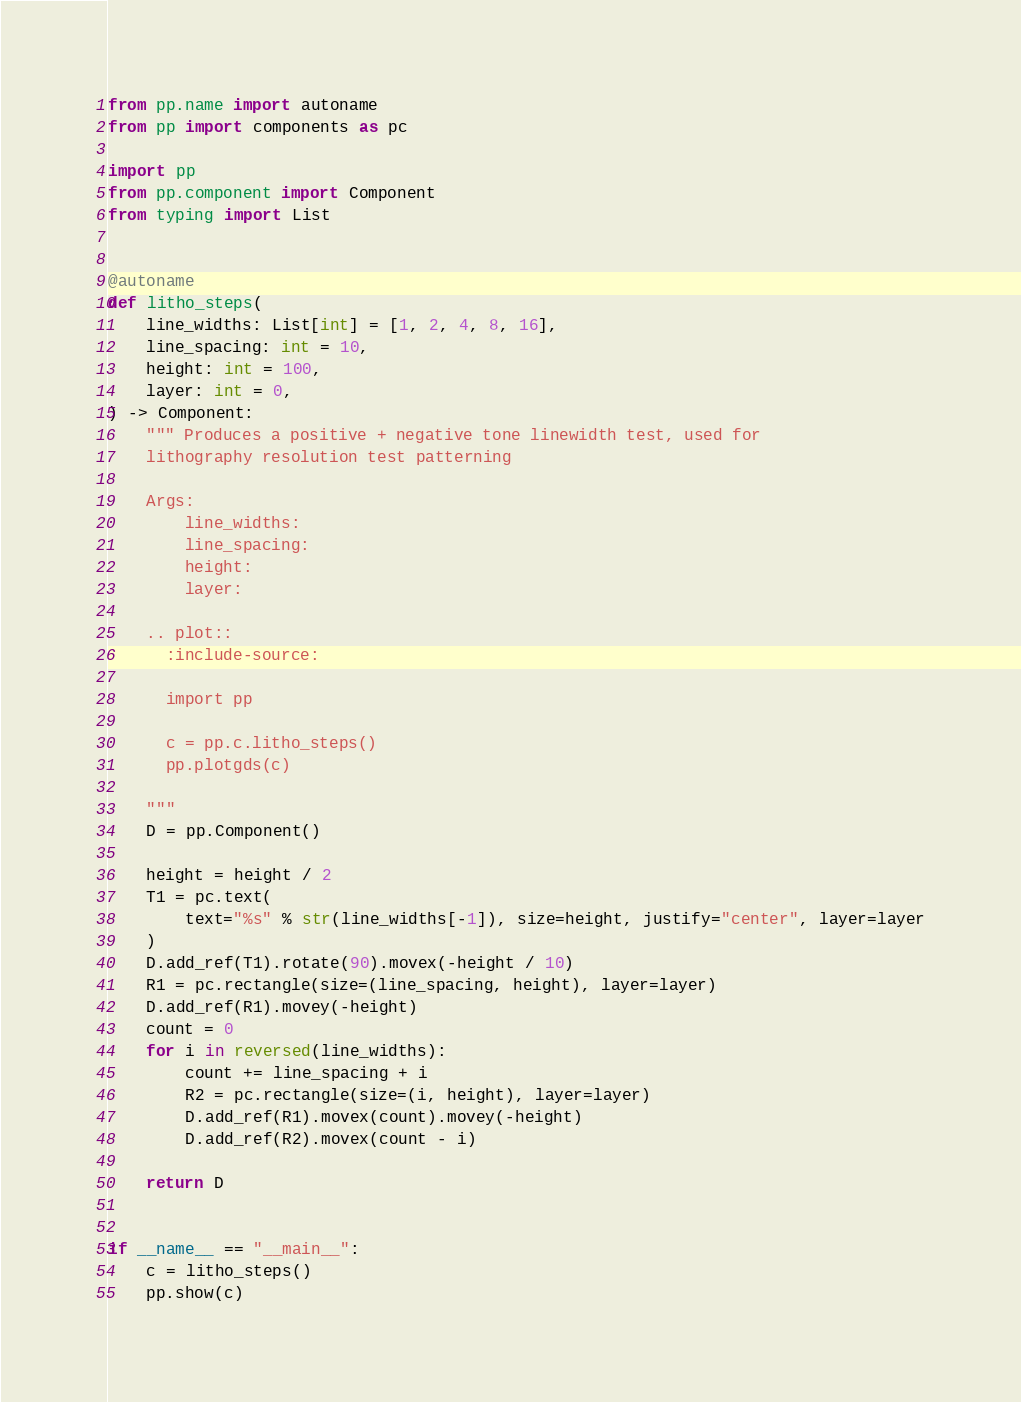<code> <loc_0><loc_0><loc_500><loc_500><_Python_>from pp.name import autoname
from pp import components as pc

import pp
from pp.component import Component
from typing import List


@autoname
def litho_steps(
    line_widths: List[int] = [1, 2, 4, 8, 16],
    line_spacing: int = 10,
    height: int = 100,
    layer: int = 0,
) -> Component:
    """ Produces a positive + negative tone linewidth test, used for
    lithography resolution test patterning

    Args:
        line_widths:
        line_spacing:
        height:
        layer:

    .. plot::
      :include-source:

      import pp

      c = pp.c.litho_steps()
      pp.plotgds(c)

    """
    D = pp.Component()

    height = height / 2
    T1 = pc.text(
        text="%s" % str(line_widths[-1]), size=height, justify="center", layer=layer
    )
    D.add_ref(T1).rotate(90).movex(-height / 10)
    R1 = pc.rectangle(size=(line_spacing, height), layer=layer)
    D.add_ref(R1).movey(-height)
    count = 0
    for i in reversed(line_widths):
        count += line_spacing + i
        R2 = pc.rectangle(size=(i, height), layer=layer)
        D.add_ref(R1).movex(count).movey(-height)
        D.add_ref(R2).movex(count - i)

    return D


if __name__ == "__main__":
    c = litho_steps()
    pp.show(c)
</code> 